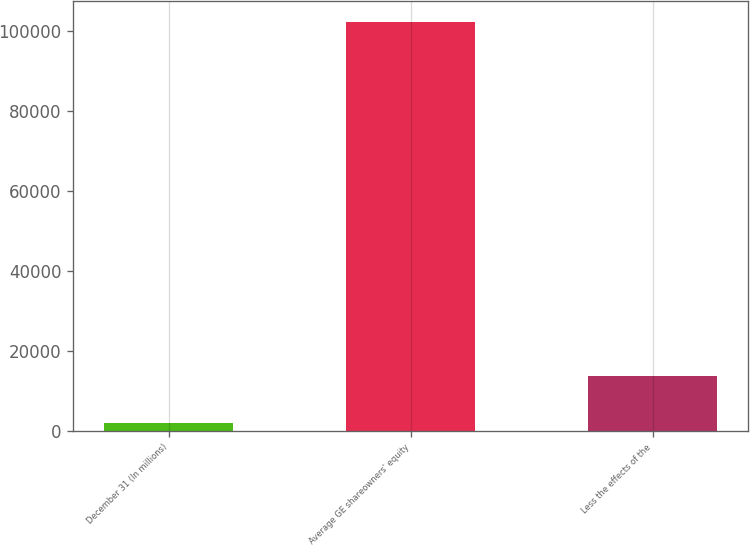<chart> <loc_0><loc_0><loc_500><loc_500><bar_chart><fcel>December 31 (In millions)<fcel>Average GE shareowners' equity<fcel>Less the effects of the<nl><fcel>2010<fcel>102360<fcel>13819<nl></chart> 